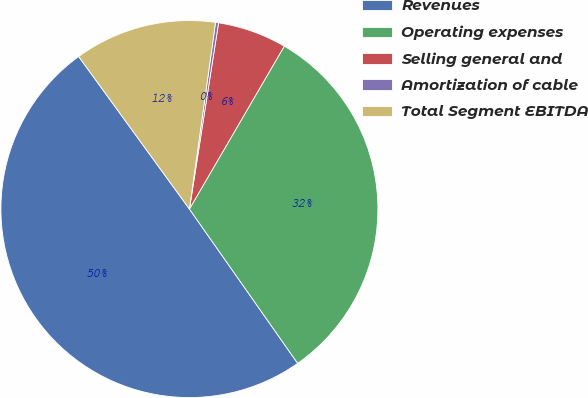Convert chart to OTSL. <chart><loc_0><loc_0><loc_500><loc_500><pie_chart><fcel>Revenues<fcel>Operating expenses<fcel>Selling general and<fcel>Amortization of cable<fcel>Total Segment EBITDA<nl><fcel>49.74%<fcel>31.87%<fcel>5.92%<fcel>0.26%<fcel>12.21%<nl></chart> 